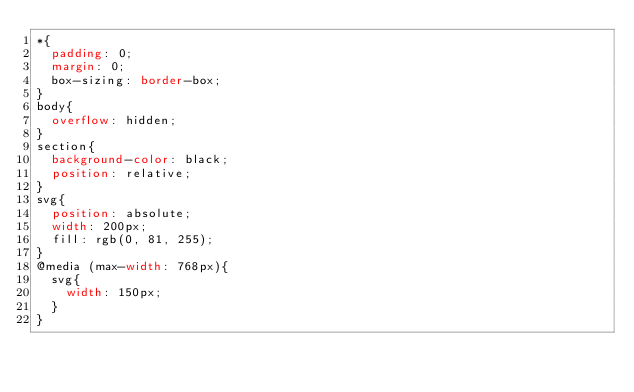<code> <loc_0><loc_0><loc_500><loc_500><_CSS_>*{
  padding: 0;
  margin: 0;
  box-sizing: border-box;
}
body{
  overflow: hidden;
}
section{
  background-color: black;
  position: relative;
}
svg{
  position: absolute;
  width: 200px;
  fill: rgb(0, 81, 255);
}
@media (max-width: 768px){
  svg{
    width: 150px;
  }
}</code> 